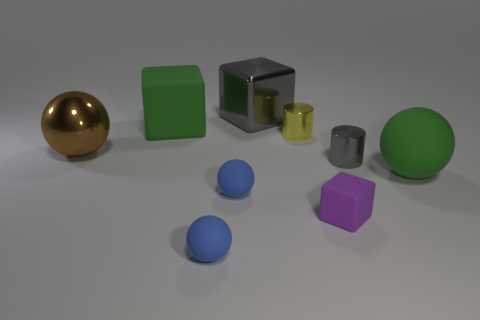Add 1 yellow rubber cylinders. How many objects exist? 10 Subtract all cylinders. How many objects are left? 7 Add 6 tiny gray shiny things. How many tiny gray shiny things exist? 7 Subtract 0 blue blocks. How many objects are left? 9 Subtract all brown rubber cubes. Subtract all small purple blocks. How many objects are left? 8 Add 3 small blue matte spheres. How many small blue matte spheres are left? 5 